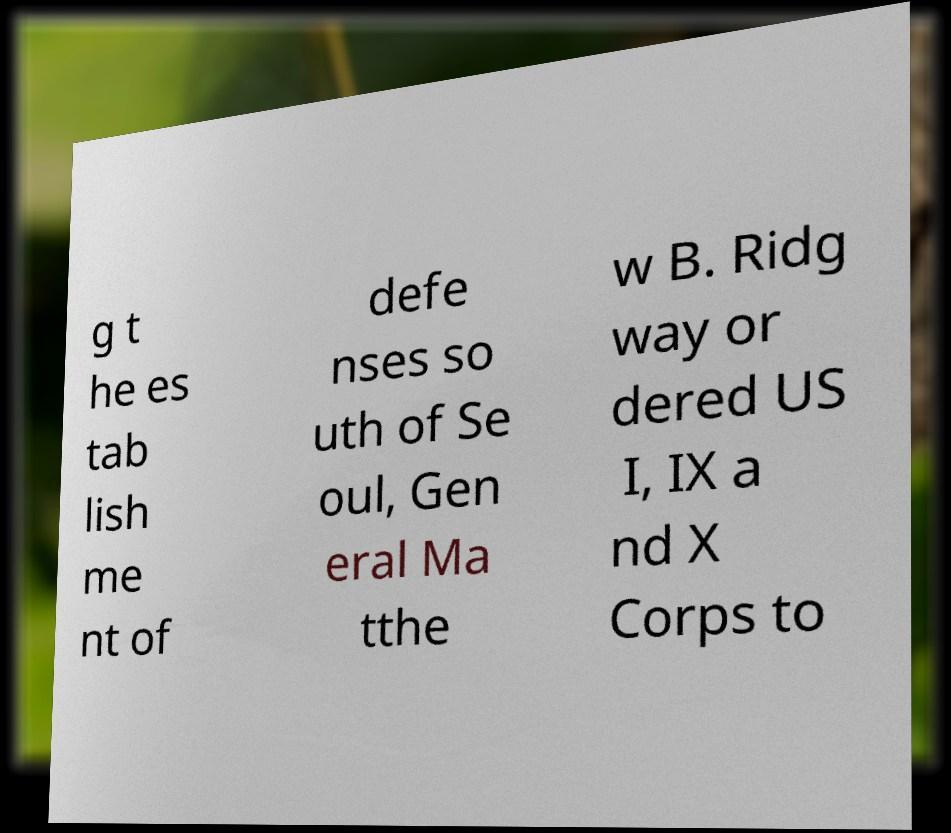There's text embedded in this image that I need extracted. Can you transcribe it verbatim? g t he es tab lish me nt of defe nses so uth of Se oul, Gen eral Ma tthe w B. Ridg way or dered US I, IX a nd X Corps to 